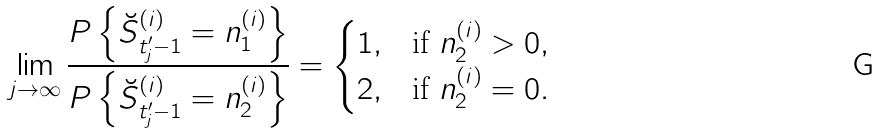Convert formula to latex. <formula><loc_0><loc_0><loc_500><loc_500>\lim _ { j \to \infty } \frac { P \left \{ \breve { S } _ { t _ { j } ^ { \prime } - 1 } ^ { ( i ) } = n _ { 1 } ^ { ( i ) } \right \} } { P \left \{ \breve { S } _ { t _ { j } ^ { \prime } - 1 } ^ { ( i ) } = n _ { 2 } ^ { ( i ) } \right \} } = \begin{cases} 1 , & \text {if} \ n _ { 2 } ^ { ( i ) } > 0 , \\ 2 , & \text {if} \ n _ { 2 } ^ { ( i ) } = 0 . \\ \end{cases}</formula> 